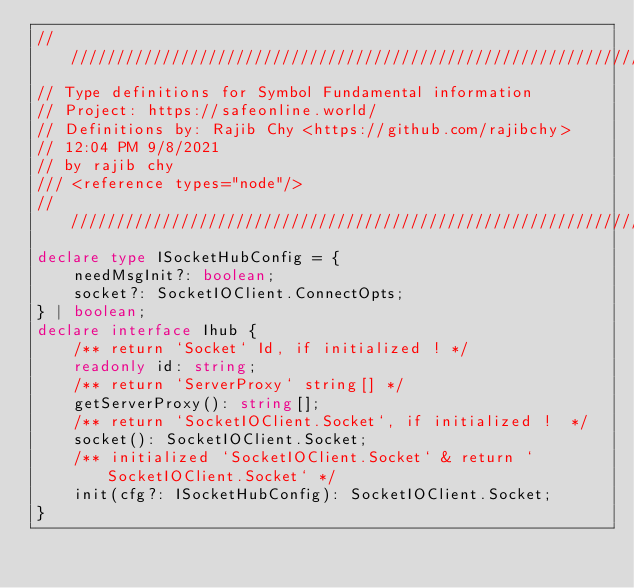Convert code to text. <code><loc_0><loc_0><loc_500><loc_500><_TypeScript_>/////////////////////////////////////////////////////////////////
// Type definitions for Symbol Fundamental information
// Project: https://safeonline.world/
// Definitions by: Rajib Chy <https://github.com/rajibchy>
// 12:04 PM 9/8/2021
// by rajib chy
/// <reference types="node"/>
////////////////////////////////////////////////////////////////
declare type ISocketHubConfig = {
    needMsgInit?: boolean;
    socket?: SocketIOClient.ConnectOpts;
} | boolean;
declare interface Ihub {
    /** return `Socket` Id, if initialized ! */
    readonly id: string;
    /** return `ServerProxy` string[] */
    getServerProxy(): string[];
    /** return `SocketIOClient.Socket`, if initialized !  */
    socket(): SocketIOClient.Socket;
    /** initialized `SocketIOClient.Socket` & return `SocketIOClient.Socket` */
    init(cfg?: ISocketHubConfig): SocketIOClient.Socket;
}</code> 